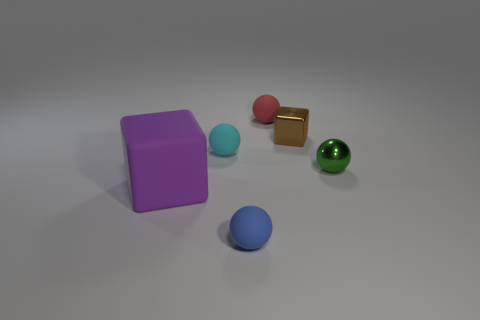What is the size of the rubber ball that is in front of the big matte block?
Your response must be concise. Small. Do the tiny blue object and the small cyan ball have the same material?
Make the answer very short. Yes. The rubber object that is left of the small blue matte sphere and on the right side of the big block is what color?
Your answer should be very brief. Cyan. Is there a gray ball of the same size as the brown cube?
Your answer should be compact. No. There is a ball that is left of the thing in front of the big purple matte cube; how big is it?
Provide a succinct answer. Small. Are there fewer big objects behind the green metal ball than big blue metallic blocks?
Your answer should be compact. No. Is the small metallic cube the same color as the large cube?
Your answer should be compact. No. The cyan ball has what size?
Provide a succinct answer. Small. What number of other small metal balls are the same color as the metallic sphere?
Ensure brevity in your answer.  0. There is a ball that is right of the rubber thing behind the tiny cyan rubber sphere; is there a tiny ball that is on the left side of it?
Keep it short and to the point. Yes. 